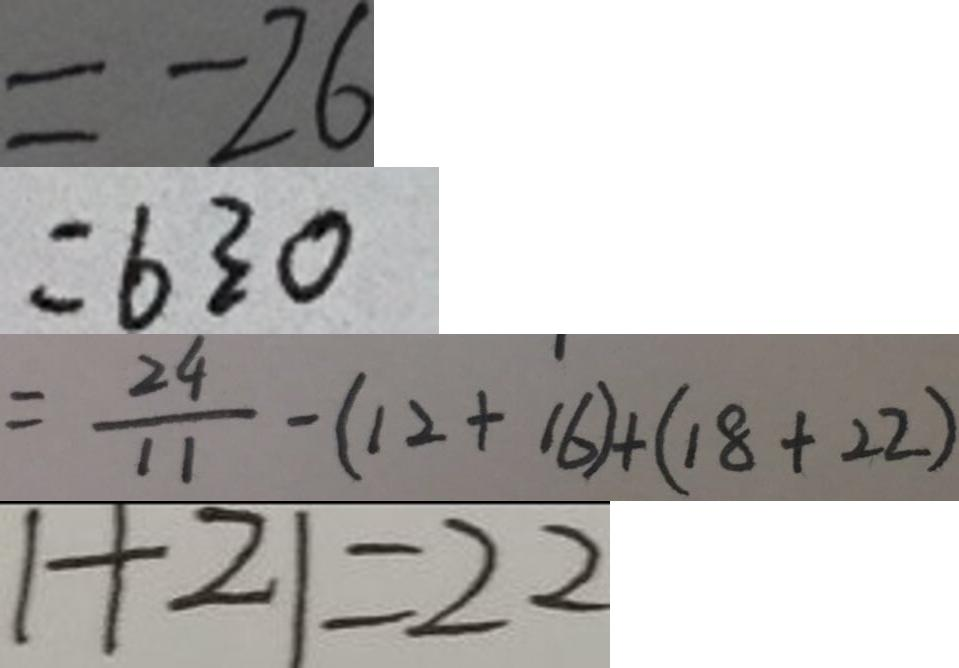<formula> <loc_0><loc_0><loc_500><loc_500>= - 2 6 
 = 6 3 0 
 = \frac { 2 4 } { 1 1 } - ( 1 2 + 1 6 ) + ( 1 8 + 2 2 ) 
 1 + 2 1 = 2 2</formula> 